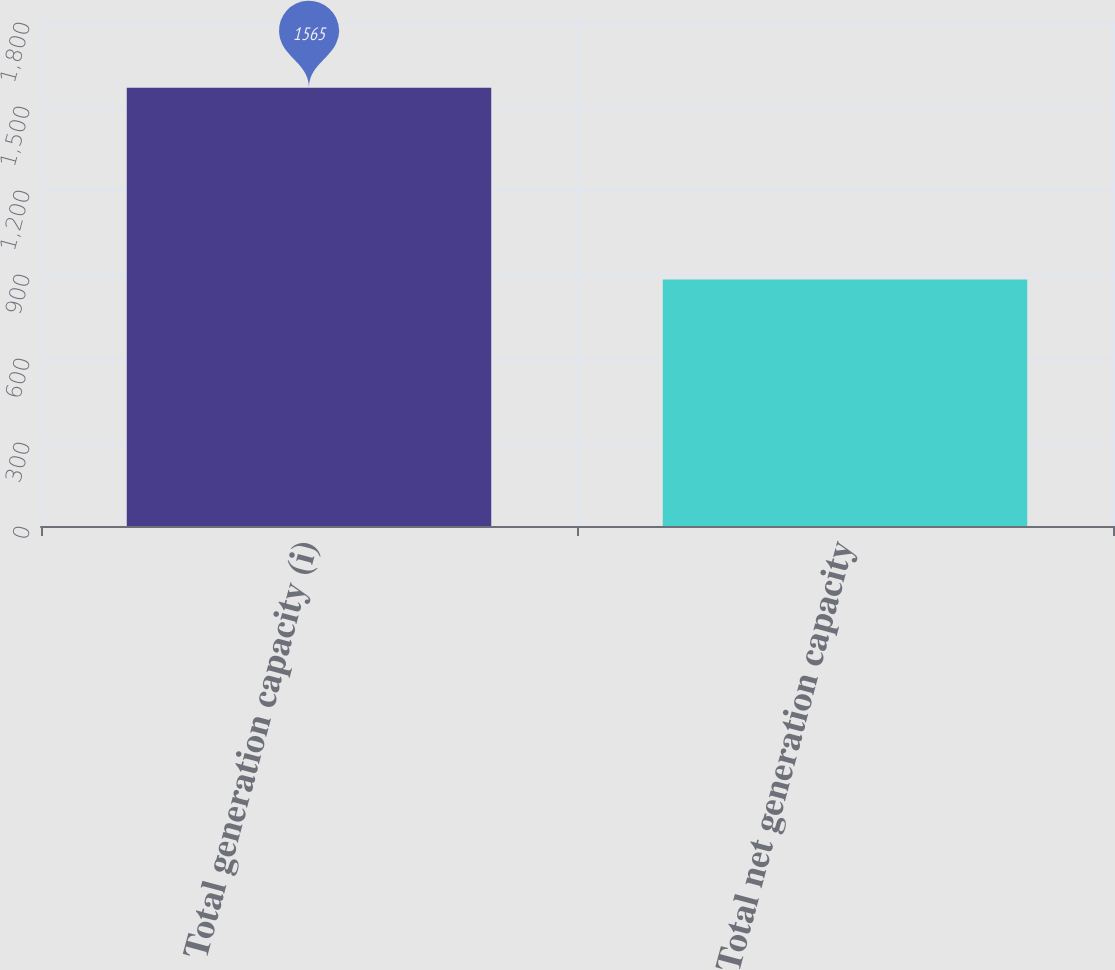<chart> <loc_0><loc_0><loc_500><loc_500><bar_chart><fcel>Total generation capacity (i)<fcel>Total net generation capacity<nl><fcel>1565<fcel>880<nl></chart> 